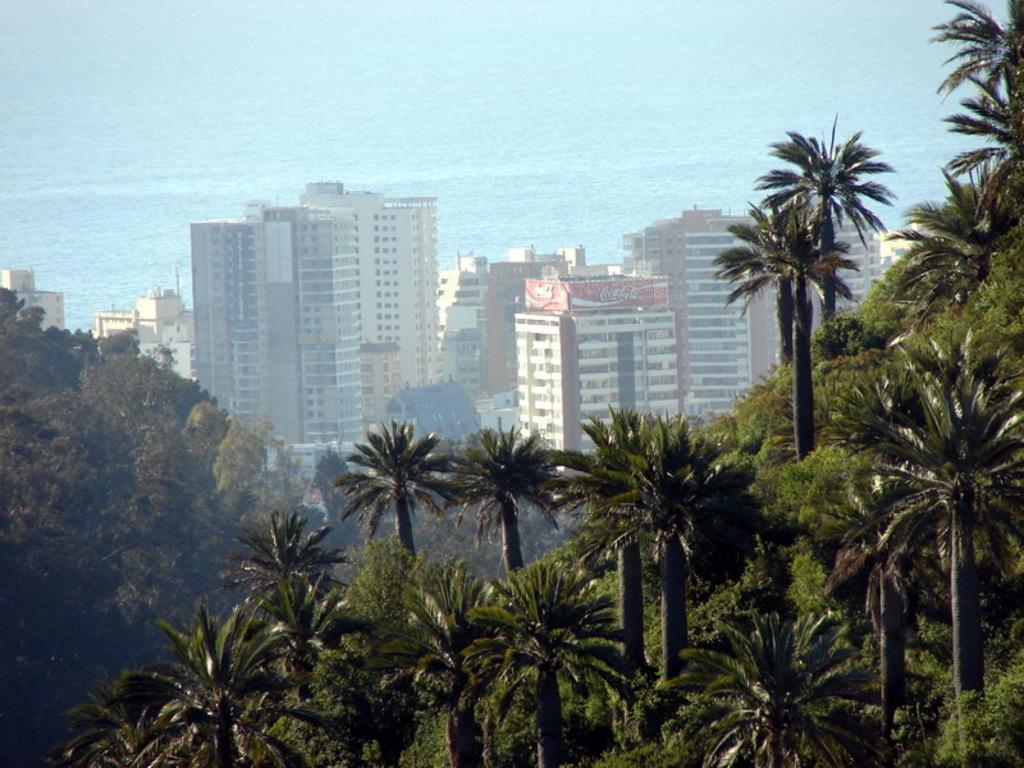Could you give a brief overview of what you see in this image? In the center of the image there are buildings and trees. In the background there is water. 